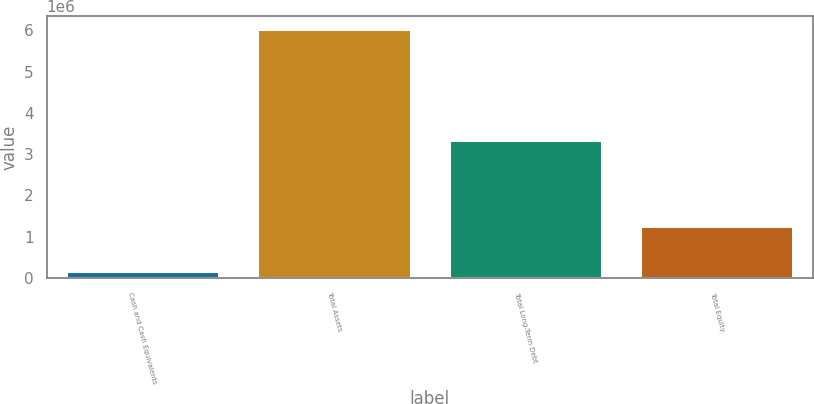Convert chart. <chart><loc_0><loc_0><loc_500><loc_500><bar_chart><fcel>Cash and Cash Equivalents<fcel>Total Assets<fcel>Total Long-Term Debt<fcel>Total Equity<nl><fcel>179845<fcel>6.04126e+06<fcel>3.35359e+06<fcel>1.25426e+06<nl></chart> 